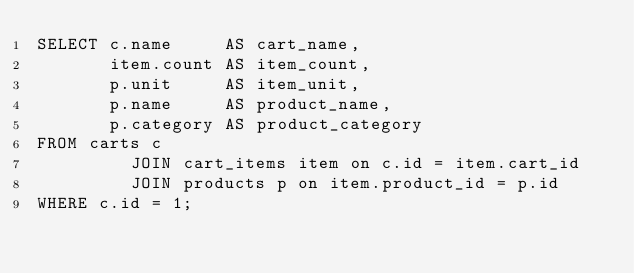Convert code to text. <code><loc_0><loc_0><loc_500><loc_500><_SQL_>SELECT c.name     AS cart_name,
       item.count AS item_count,
       p.unit     AS item_unit,
       p.name     AS product_name,
       p.category AS product_category
FROM carts c
         JOIN cart_items item on c.id = item.cart_id
         JOIN products p on item.product_id = p.id
WHERE c.id = 1;
</code> 